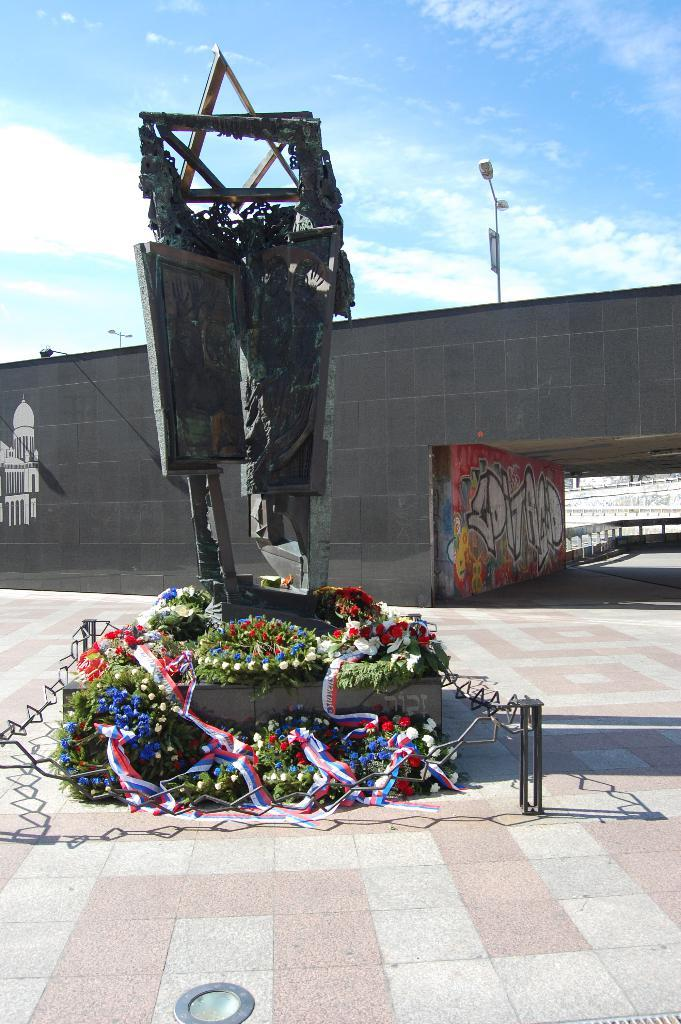What is the main subject of the image? There is a memorial in the image. What can be seen near the memorial? There are flower bouquets in the image. What type of structure is visible in the image? There is a wall in the image. What other objects can be seen in the image? There are poles in the image. What is visible in the background of the image? The sky with clouds is visible in the background of the image. Can you see a crate being used for swimming in the image? There is no crate or swimming activity present in the image. Where is the spot where people can gather to remember the memorial? The image does not show a specific spot for gathering, but it does show the memorial itself. 